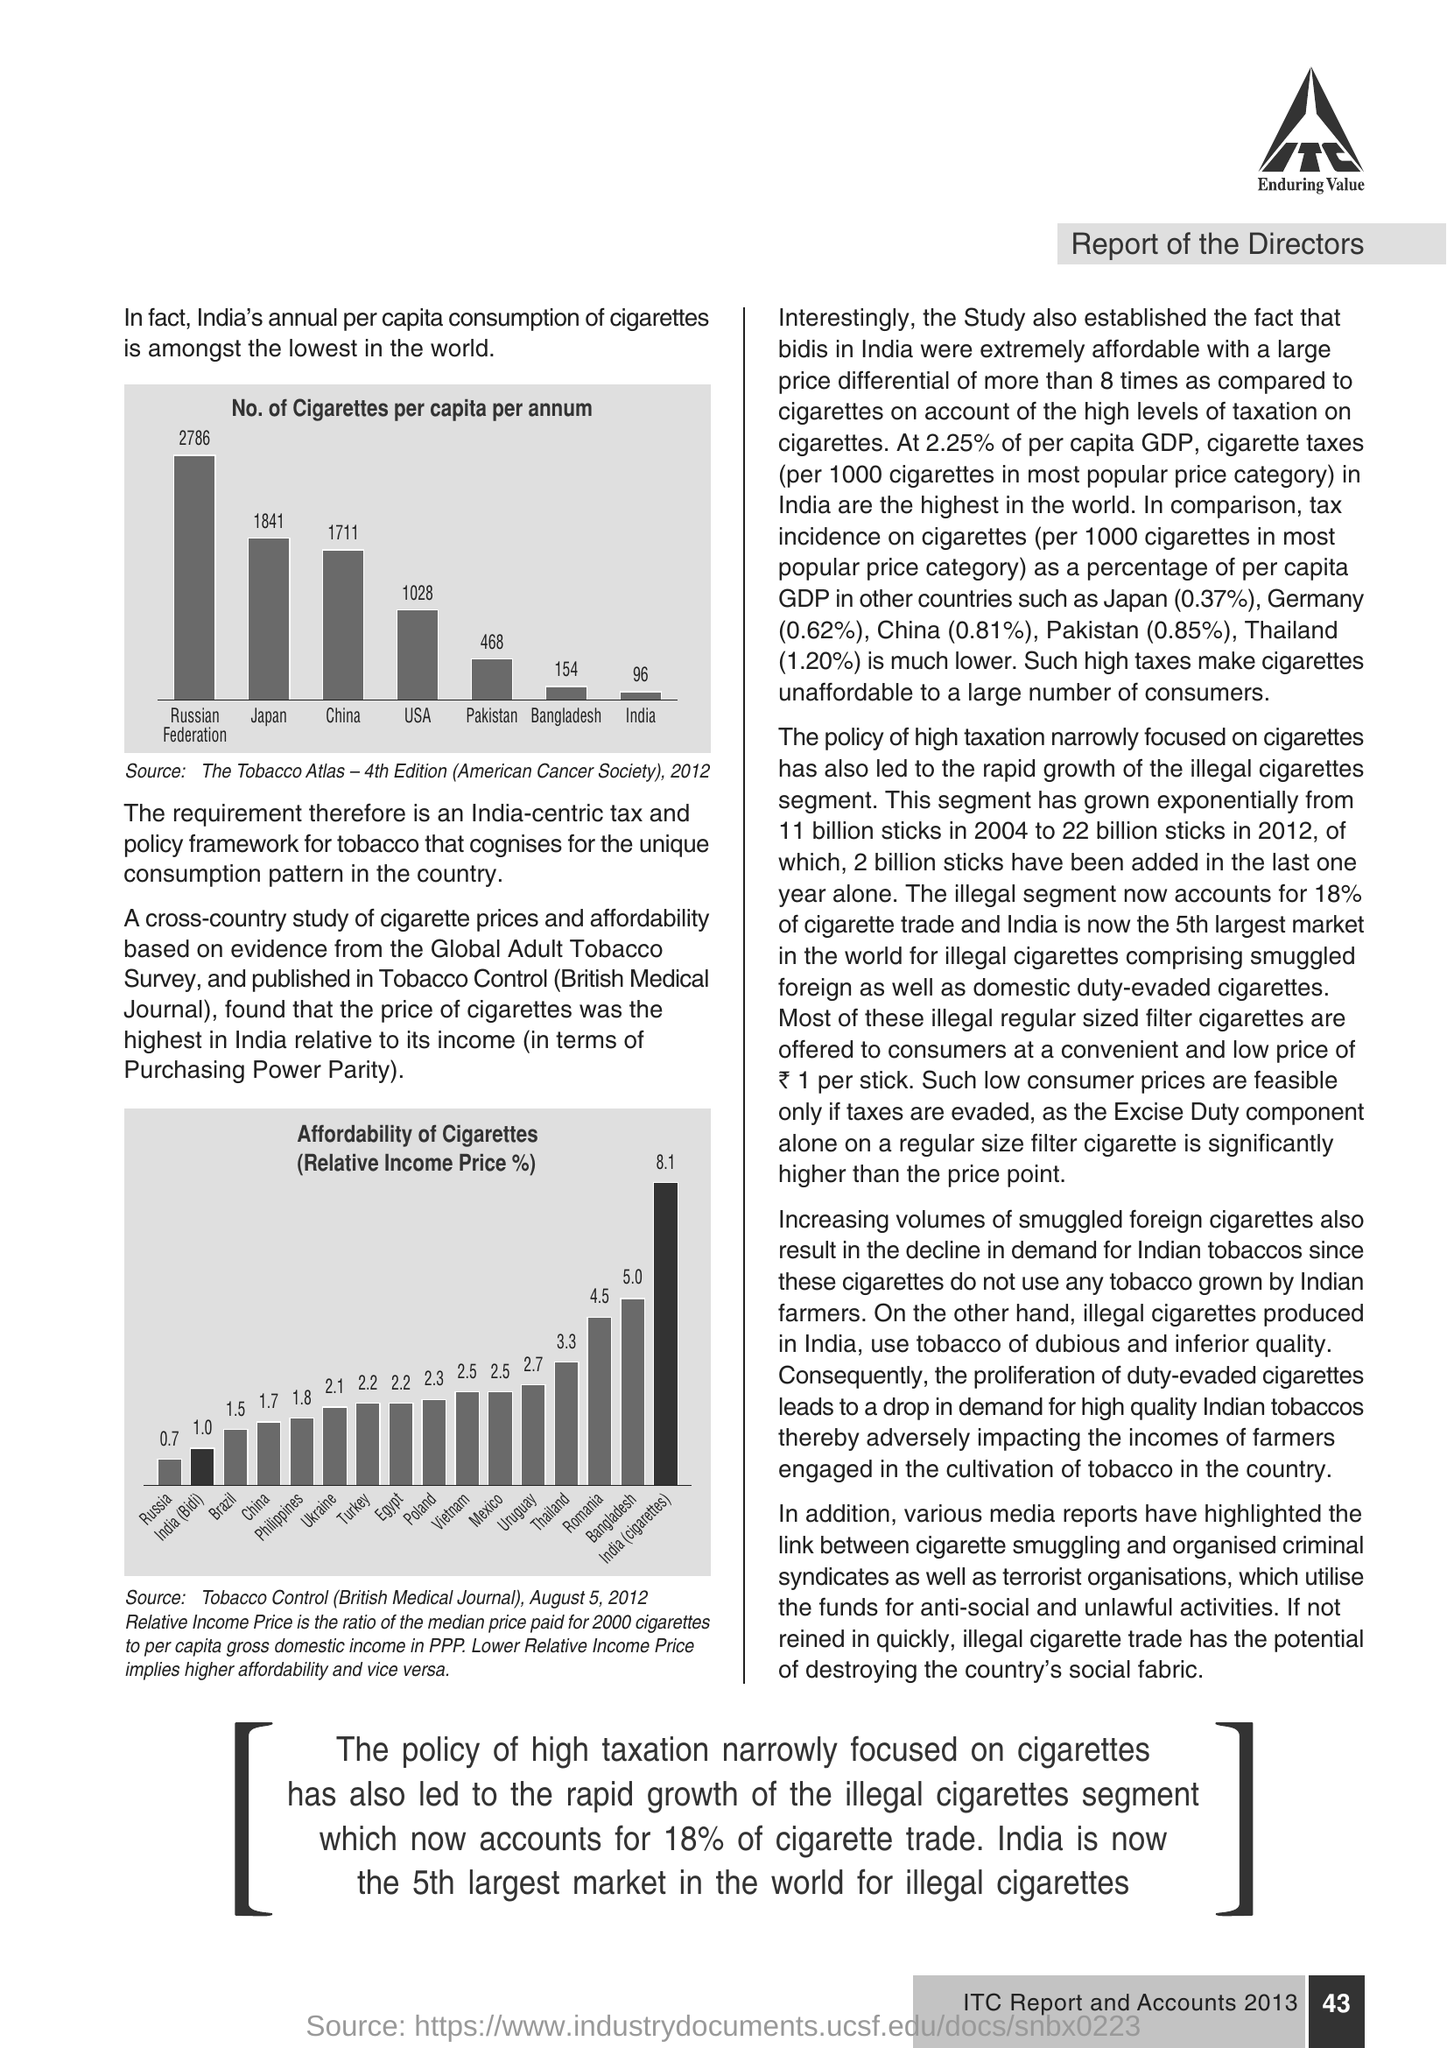What is the  %  of GDP in Pakistan ?
Offer a terse response. 0.85%. 